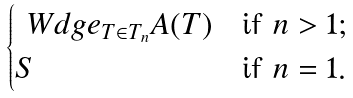<formula> <loc_0><loc_0><loc_500><loc_500>\begin{cases} \ W d g e _ { T \in T _ { n } } A ( T ) & \text {if $n > 1$} ; \\ S & \text {if $n = 1$} . \end{cases}</formula> 